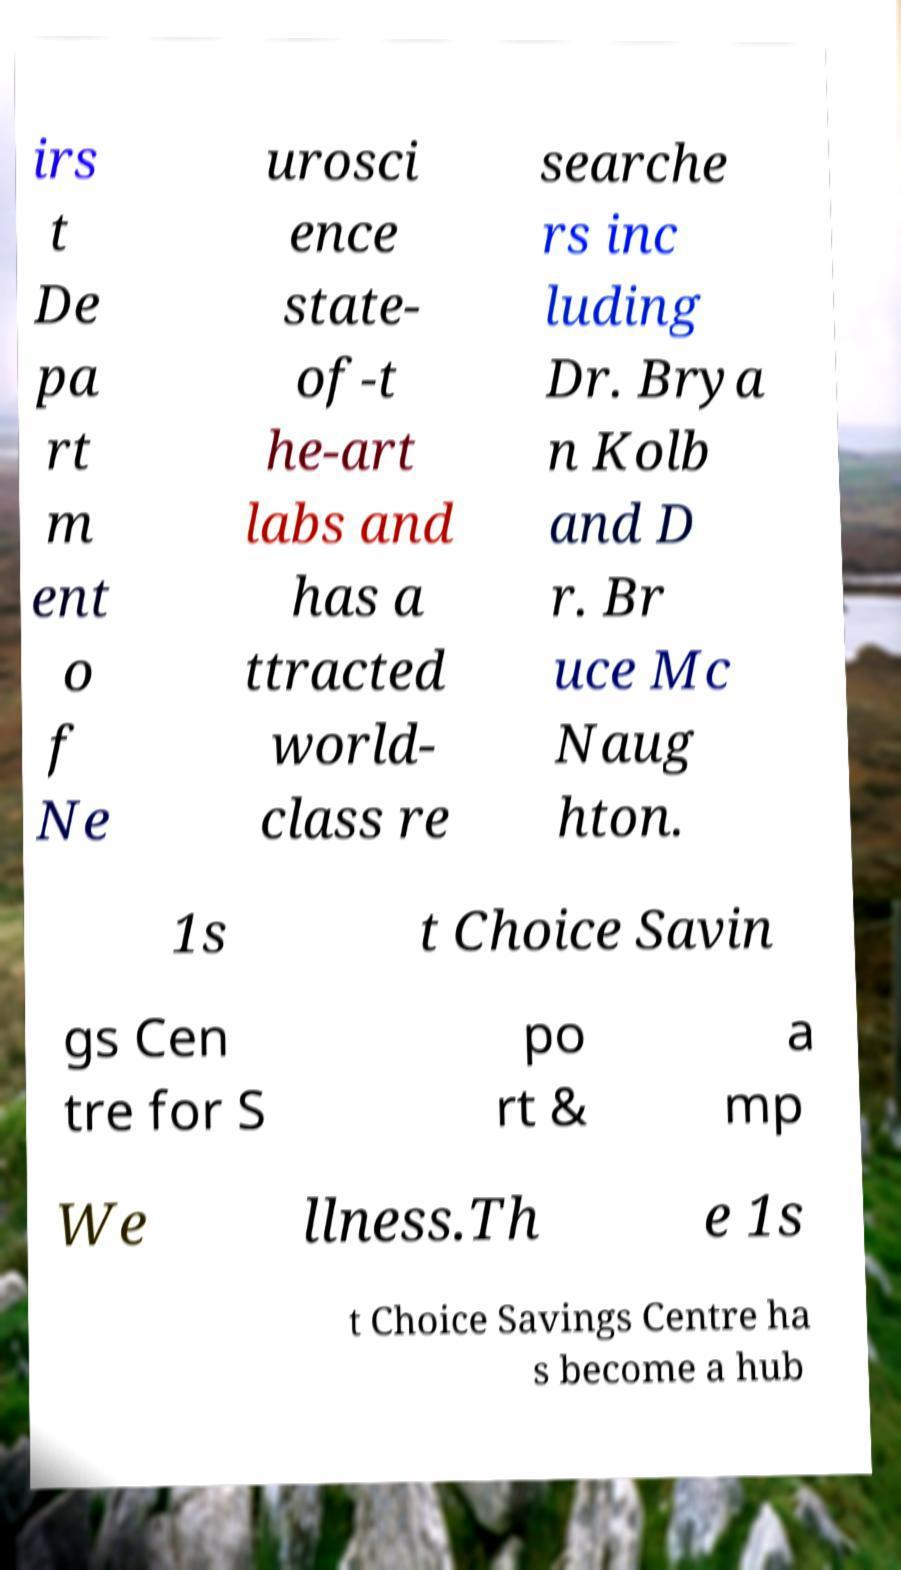Can you accurately transcribe the text from the provided image for me? irs t De pa rt m ent o f Ne urosci ence state- of-t he-art labs and has a ttracted world- class re searche rs inc luding Dr. Brya n Kolb and D r. Br uce Mc Naug hton. 1s t Choice Savin gs Cen tre for S po rt & a mp We llness.Th e 1s t Choice Savings Centre ha s become a hub 